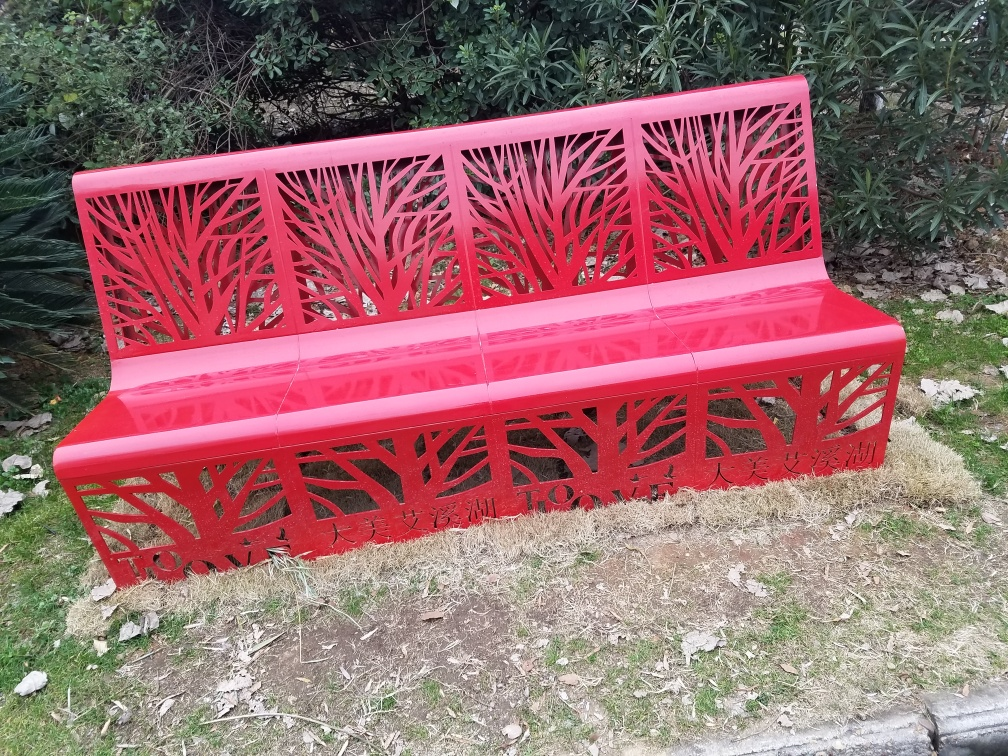How could this bench be used in urban design? This bench could be installed in parks, along sidewalks, or in community spaces to provide both functional seating and a decorative element. Its bold color and design could enhance the visual appeal of public spaces and encourage people to spend more time outdoors. 